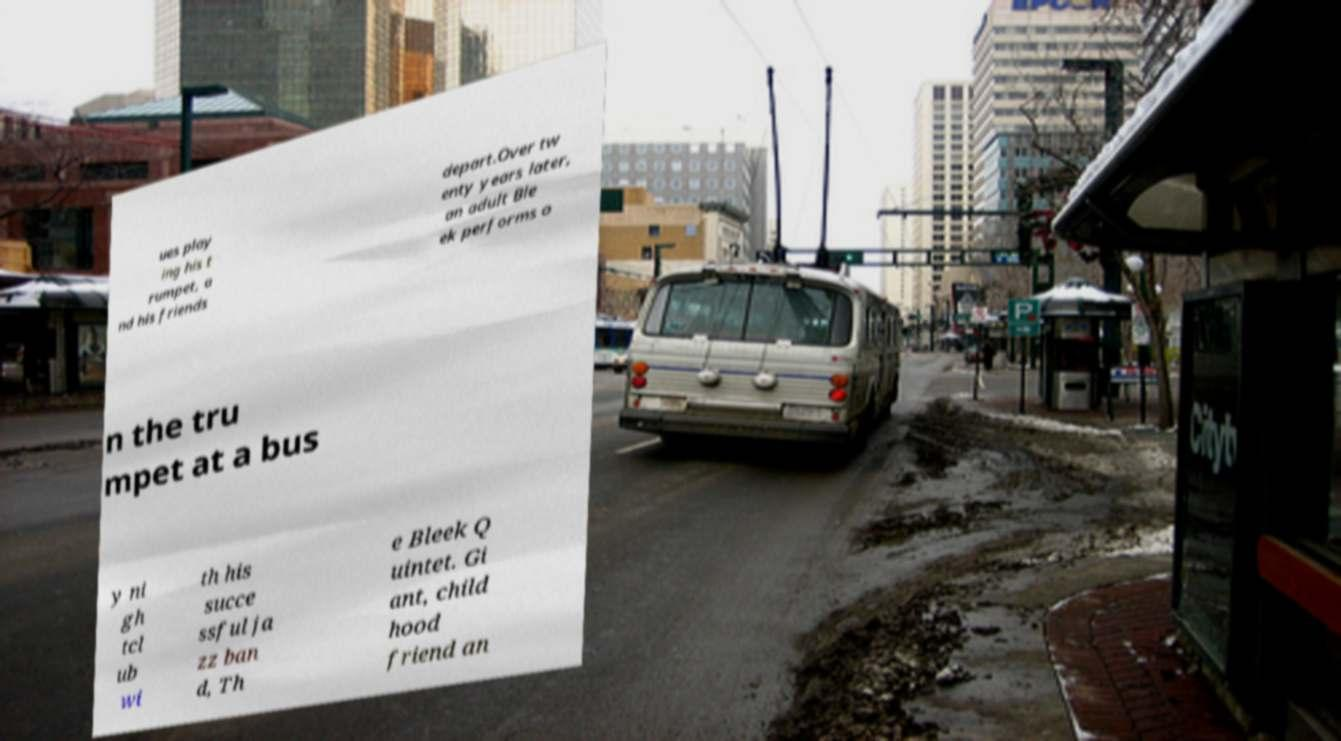Please identify and transcribe the text found in this image. ues play ing his t rumpet, a nd his friends depart.Over tw enty years later, an adult Ble ek performs o n the tru mpet at a bus y ni gh tcl ub wi th his succe ssful ja zz ban d, Th e Bleek Q uintet. Gi ant, child hood friend an 